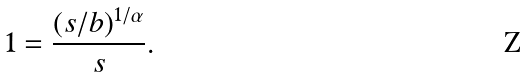<formula> <loc_0><loc_0><loc_500><loc_500>1 = \frac { ( s / b ) ^ { 1 / \alpha } } { s } .</formula> 